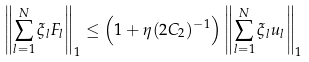<formula> <loc_0><loc_0><loc_500><loc_500>\left \| \sum _ { l = 1 } ^ { N } \xi _ { l } F _ { l } \right \| _ { 1 } \leq \left ( 1 + \eta ( 2 C _ { 2 } ) ^ { - 1 } \right ) \left \| \sum _ { l = 1 } ^ { N } \xi _ { l } u _ { l } \right \| _ { 1 }</formula> 